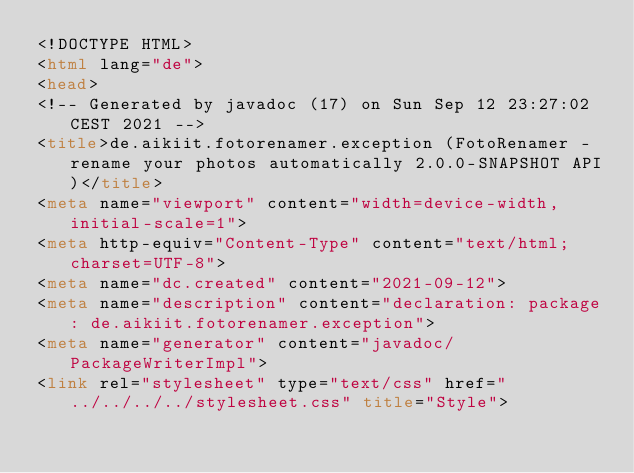Convert code to text. <code><loc_0><loc_0><loc_500><loc_500><_HTML_><!DOCTYPE HTML>
<html lang="de">
<head>
<!-- Generated by javadoc (17) on Sun Sep 12 23:27:02 CEST 2021 -->
<title>de.aikiit.fotorenamer.exception (FotoRenamer - rename your photos automatically 2.0.0-SNAPSHOT API)</title>
<meta name="viewport" content="width=device-width, initial-scale=1">
<meta http-equiv="Content-Type" content="text/html; charset=UTF-8">
<meta name="dc.created" content="2021-09-12">
<meta name="description" content="declaration: package: de.aikiit.fotorenamer.exception">
<meta name="generator" content="javadoc/PackageWriterImpl">
<link rel="stylesheet" type="text/css" href="../../../../stylesheet.css" title="Style"></code> 